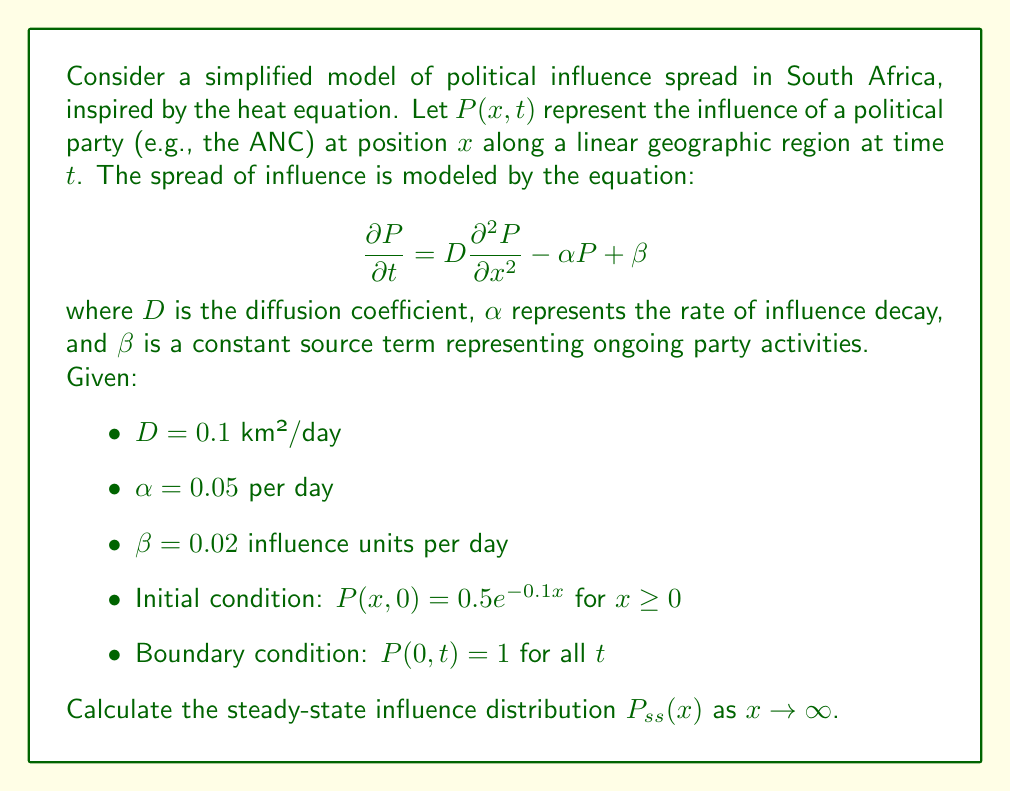Can you answer this question? To solve this problem, we need to follow these steps:

1) For the steady-state solution, the time derivative becomes zero:

   $$\frac{\partial P}{\partial t} = 0$$

2) This reduces our equation to:

   $$0 = D\frac{d^2 P_{ss}}{dx^2} - \alpha P_{ss} + \beta$$

3) Rearranging:

   $$D\frac{d^2 P_{ss}}{dx^2} - \alpha P_{ss} = -\beta$$

4) This is a second-order linear differential equation. The general solution is of the form:

   $$P_{ss}(x) = Ae^{mx} + Be^{-mx} + \frac{\beta}{\alpha}$$

   where $m = \sqrt{\frac{\alpha}{D}}$

5) Substituting the given values:

   $$m = \sqrt{\frac{0.05}{0.1}} = \sqrt{0.5} \approx 0.7071$$

6) As $x \to \infty$, we expect the influence to approach a constant value or zero. Therefore, $A$ must be zero to avoid exponential growth.

7) Our solution becomes:

   $$P_{ss}(x) = Be^{-0.7071x} + \frac{0.02}{0.05} = Be^{-0.7071x} + 0.4$$

8) To find $B$, we use the boundary condition $P(0,t) = 1$:

   $$1 = B + 0.4$$
   $$B = 0.6$$

9) Therefore, the steady-state solution is:

   $$P_{ss}(x) = 0.6e^{-0.7071x} + 0.4$$

This solution represents the long-term influence distribution of the political party along the geographic region.
Answer: $$P_{ss}(x) = 0.6e^{-0.7071x} + 0.4$$ 